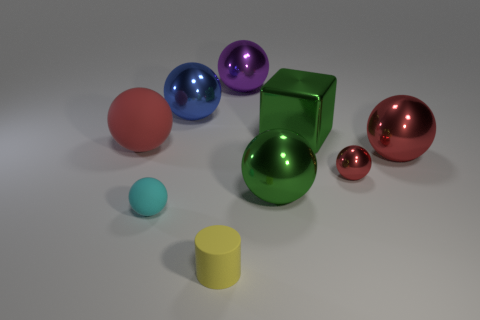Are there any cyan matte spheres to the right of the tiny rubber object in front of the small rubber object that is left of the yellow cylinder?
Provide a succinct answer. No. Are there any other balls that have the same size as the red rubber sphere?
Your response must be concise. Yes. What size is the blue object that is left of the green ball?
Provide a short and direct response. Large. What is the color of the metal ball that is on the left side of the large thing behind the metallic sphere left of the tiny yellow object?
Offer a terse response. Blue. What is the color of the rubber sphere in front of the large red sphere on the right side of the big matte sphere?
Make the answer very short. Cyan. Is the number of tiny yellow rubber things that are in front of the large block greater than the number of yellow cylinders that are behind the small yellow object?
Keep it short and to the point. Yes. Is the material of the purple ball that is on the right side of the small cyan rubber object the same as the large red object that is to the right of the yellow matte cylinder?
Offer a very short reply. Yes. There is a large green shiny block; are there any red rubber objects behind it?
Provide a short and direct response. No. How many yellow things are either cubes or big things?
Make the answer very short. 0. Does the cyan thing have the same material as the large red object that is on the left side of the tiny red shiny thing?
Offer a terse response. Yes. 